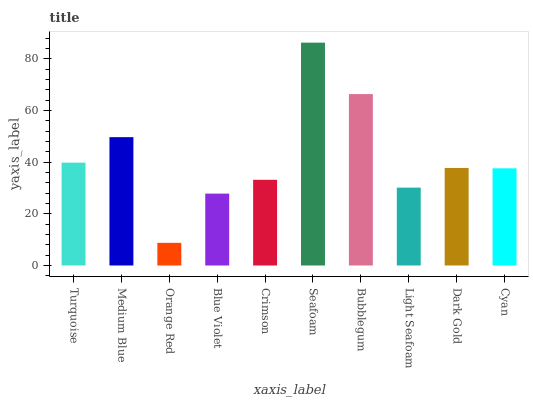Is Orange Red the minimum?
Answer yes or no. Yes. Is Seafoam the maximum?
Answer yes or no. Yes. Is Medium Blue the minimum?
Answer yes or no. No. Is Medium Blue the maximum?
Answer yes or no. No. Is Medium Blue greater than Turquoise?
Answer yes or no. Yes. Is Turquoise less than Medium Blue?
Answer yes or no. Yes. Is Turquoise greater than Medium Blue?
Answer yes or no. No. Is Medium Blue less than Turquoise?
Answer yes or no. No. Is Dark Gold the high median?
Answer yes or no. Yes. Is Cyan the low median?
Answer yes or no. Yes. Is Crimson the high median?
Answer yes or no. No. Is Orange Red the low median?
Answer yes or no. No. 